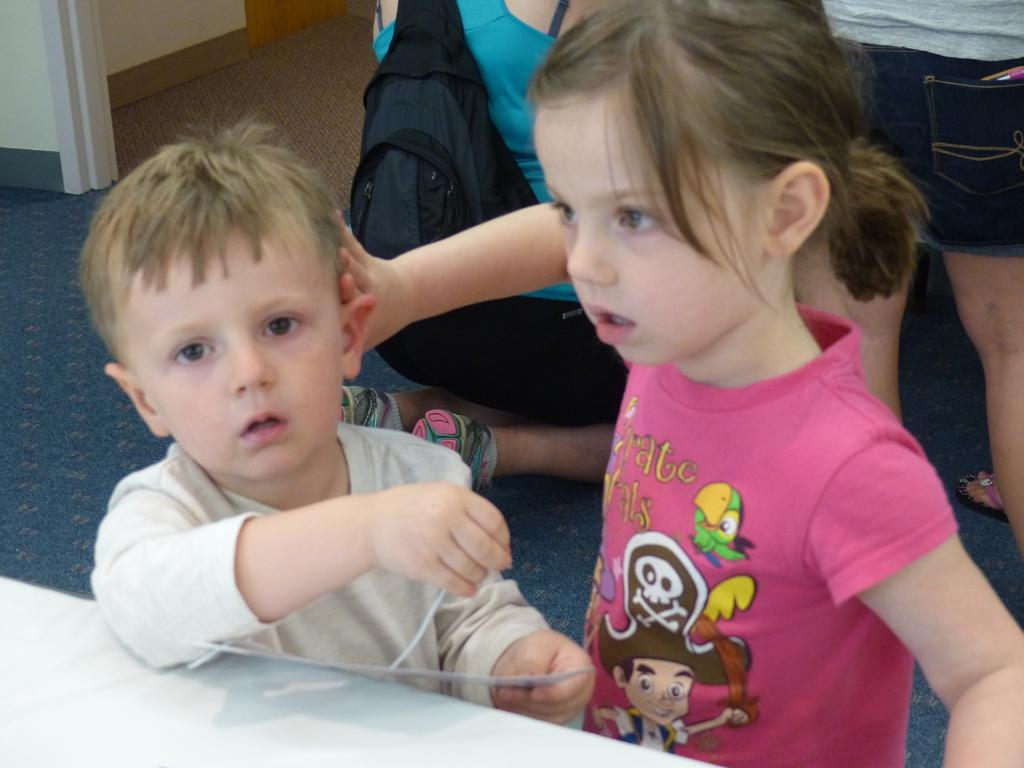How many people are visible in the image? There are two people visible in the image, a girl and a boy. What can be seen in the background of the image? There are people in the background of the image. What is the floor covering in the image? The floor has carpets. What is one person wearing that is not clothing? One person is wearing a bag. What type of fruit can be seen growing on the trees in the image? There are no trees or fruit visible in the image. 